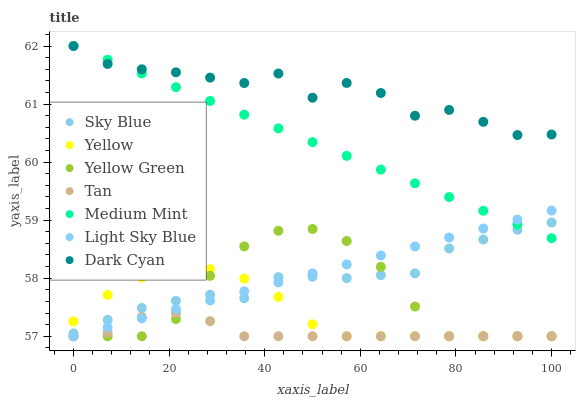Does Tan have the minimum area under the curve?
Answer yes or no. Yes. Does Dark Cyan have the maximum area under the curve?
Answer yes or no. Yes. Does Yellow Green have the minimum area under the curve?
Answer yes or no. No. Does Yellow Green have the maximum area under the curve?
Answer yes or no. No. Is Medium Mint the smoothest?
Answer yes or no. Yes. Is Dark Cyan the roughest?
Answer yes or no. Yes. Is Yellow Green the smoothest?
Answer yes or no. No. Is Yellow Green the roughest?
Answer yes or no. No. Does Yellow Green have the lowest value?
Answer yes or no. Yes. Does Dark Cyan have the lowest value?
Answer yes or no. No. Does Dark Cyan have the highest value?
Answer yes or no. Yes. Does Yellow Green have the highest value?
Answer yes or no. No. Is Yellow Green less than Dark Cyan?
Answer yes or no. Yes. Is Dark Cyan greater than Yellow?
Answer yes or no. Yes. Does Light Sky Blue intersect Sky Blue?
Answer yes or no. Yes. Is Light Sky Blue less than Sky Blue?
Answer yes or no. No. Is Light Sky Blue greater than Sky Blue?
Answer yes or no. No. Does Yellow Green intersect Dark Cyan?
Answer yes or no. No. 